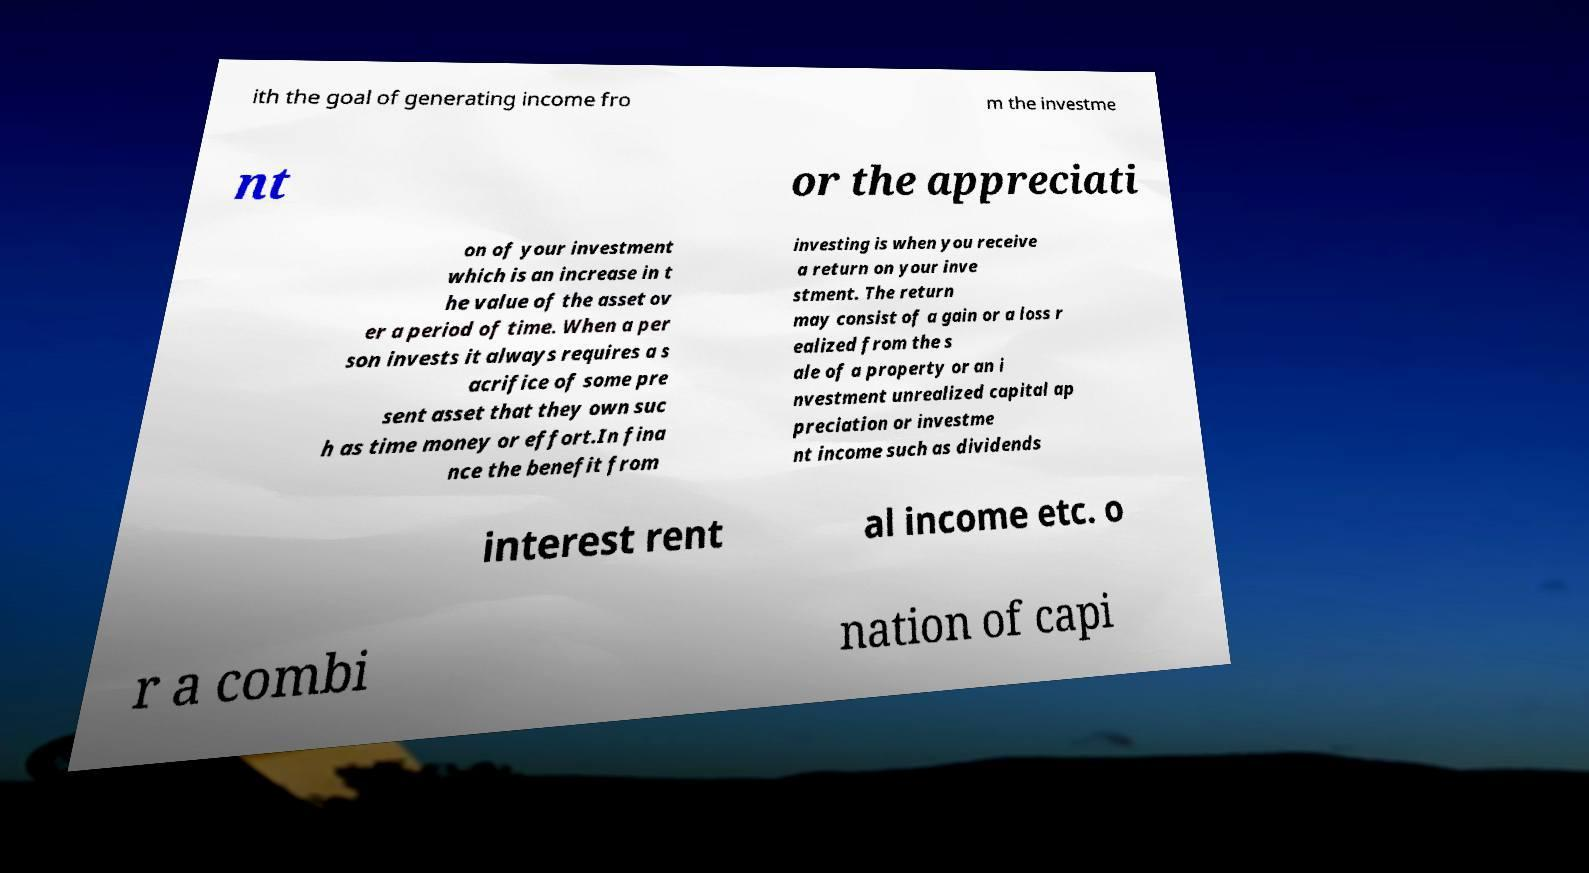Can you accurately transcribe the text from the provided image for me? ith the goal of generating income fro m the investme nt or the appreciati on of your investment which is an increase in t he value of the asset ov er a period of time. When a per son invests it always requires a s acrifice of some pre sent asset that they own suc h as time money or effort.In fina nce the benefit from investing is when you receive a return on your inve stment. The return may consist of a gain or a loss r ealized from the s ale of a property or an i nvestment unrealized capital ap preciation or investme nt income such as dividends interest rent al income etc. o r a combi nation of capi 